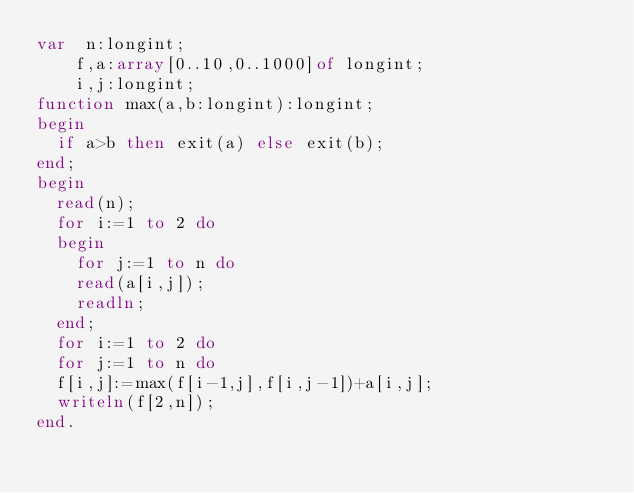<code> <loc_0><loc_0><loc_500><loc_500><_Pascal_>var  n:longint;
    f,a:array[0..10,0..1000]of longint;
    i,j:longint;
function max(a,b:longint):longint;
begin
  if a>b then exit(a) else exit(b);
end;
begin
  read(n);
  for i:=1 to 2 do
  begin
    for j:=1 to n do
    read(a[i,j]);
    readln;
  end;
  for i:=1 to 2 do
  for j:=1 to n do
  f[i,j]:=max(f[i-1,j],f[i,j-1])+a[i,j];
  writeln(f[2,n]);
end.
</code> 